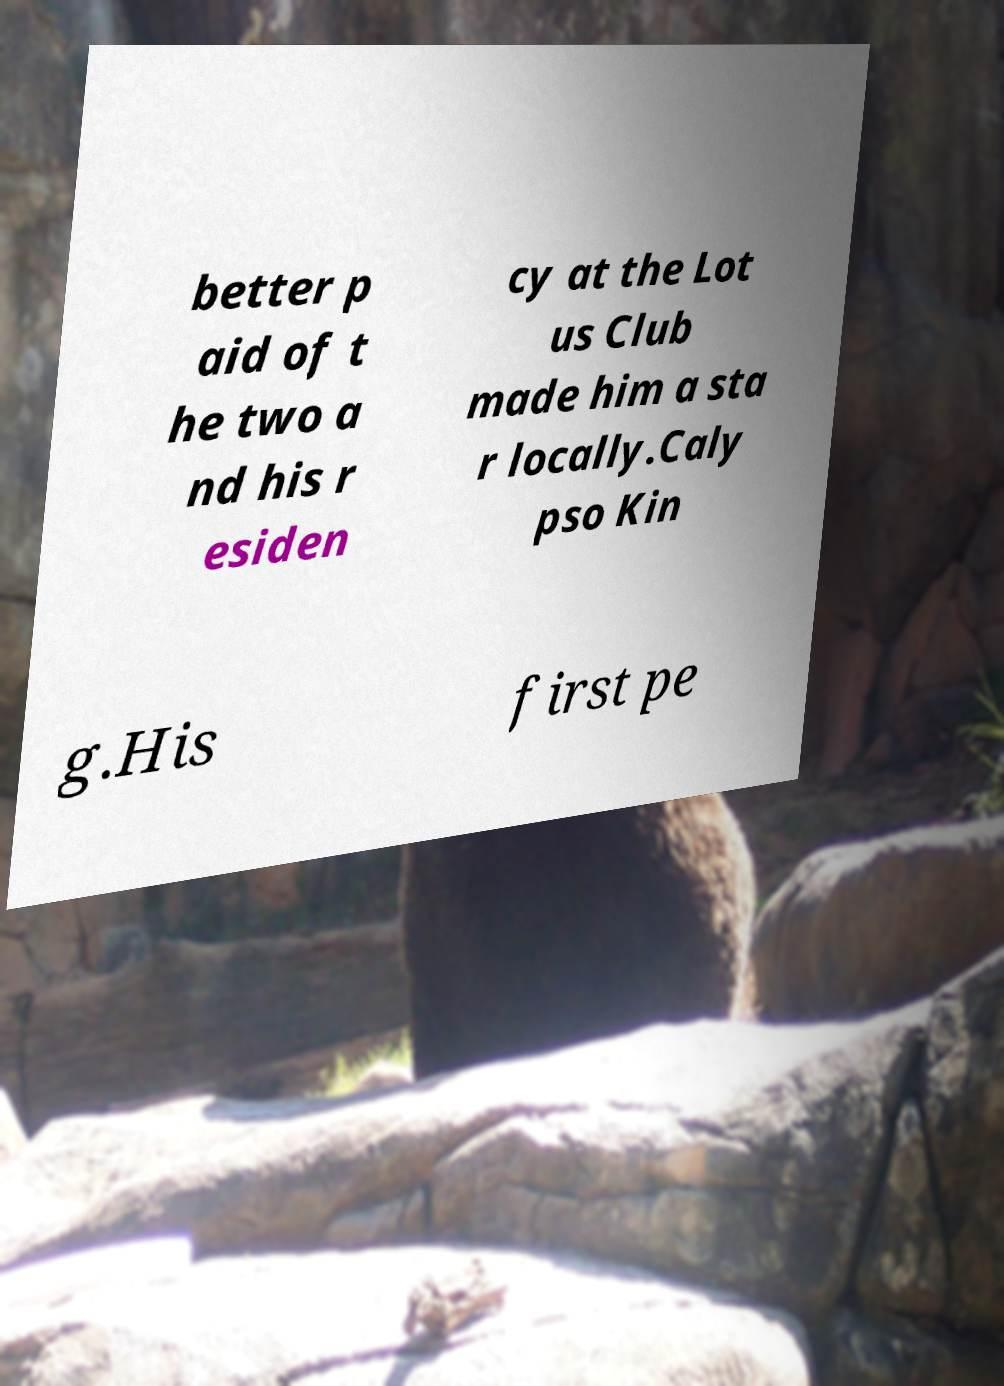I need the written content from this picture converted into text. Can you do that? better p aid of t he two a nd his r esiden cy at the Lot us Club made him a sta r locally.Caly pso Kin g.His first pe 